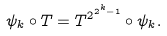<formula> <loc_0><loc_0><loc_500><loc_500>\psi _ { k } \circ T = T ^ { 2 ^ { 2 ^ { k } - 1 } } \circ \psi _ { k } .</formula> 